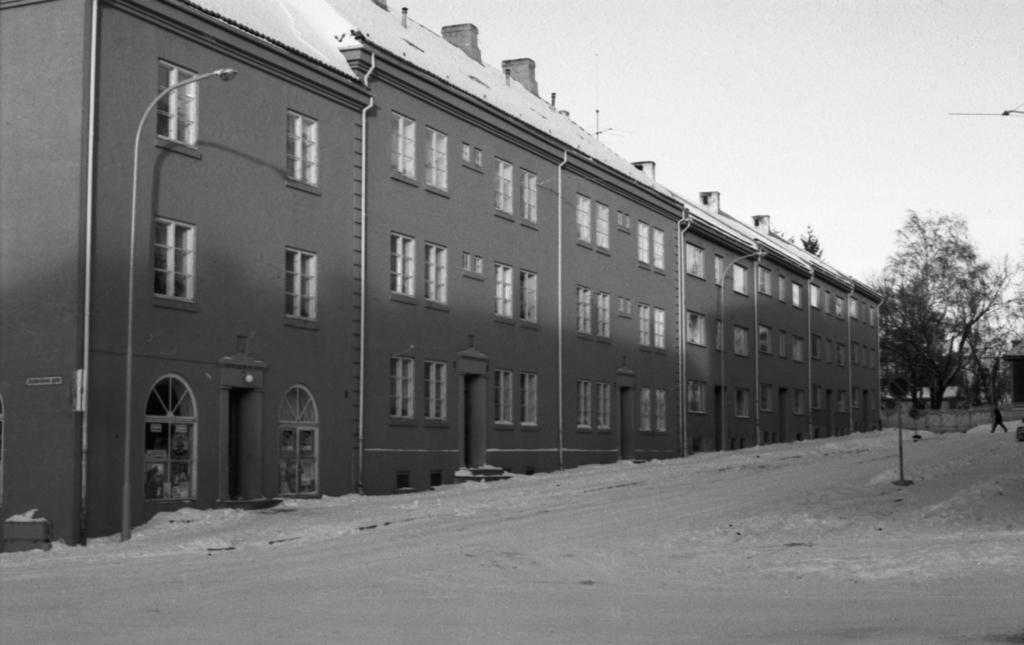How would you summarize this image in a sentence or two? In this picture there is a building in the middle, on the right side there are some trees, a person walking on the road, at the bottom there is a road, on the left side there is a light pole, pipeline visible, in the top right there is the sky. 